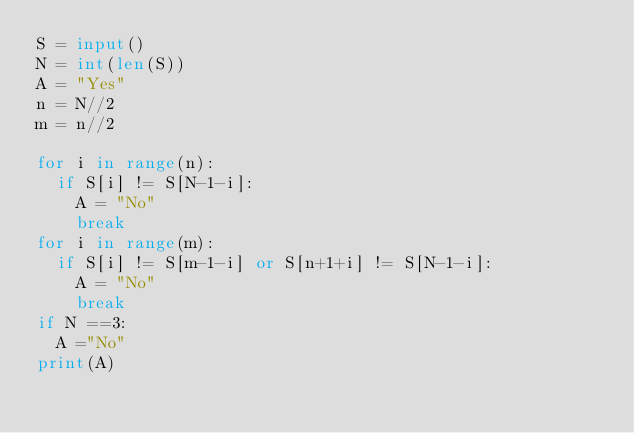Convert code to text. <code><loc_0><loc_0><loc_500><loc_500><_Python_>S = input()
N = int(len(S))
A = "Yes"
n = N//2
m = n//2
 
for i in range(n):
  if S[i] != S[N-1-i]:
    A = "No"
    break
for i in range(m):
  if S[i] != S[m-1-i] or S[n+1+i] != S[N-1-i]:
    A = "No"
    break
if N ==3:
  A ="No"
print(A)</code> 